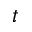Convert formula to latex. <formula><loc_0><loc_0><loc_500><loc_500>t</formula> 